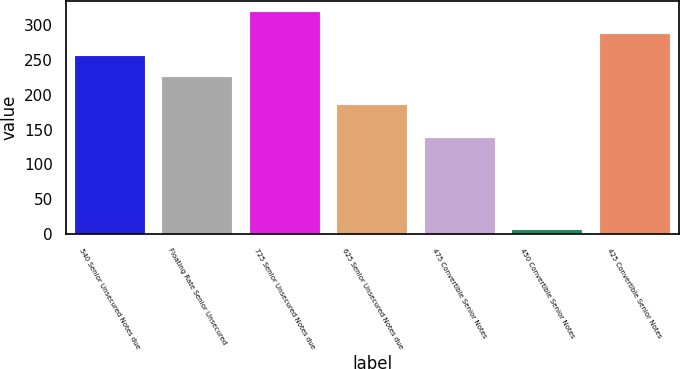Convert chart to OTSL. <chart><loc_0><loc_0><loc_500><loc_500><bar_chart><fcel>540 Senior Unsecured Notes due<fcel>Floating Rate Senior Unsecured<fcel>725 Senior Unsecured Notes due<fcel>625 Senior Unsecured Notes due<fcel>475 Convertible Senior Notes<fcel>450 Convertible Senior Notes<fcel>425 Convertible Senior Notes<nl><fcel>255.93<fcel>225<fcel>318.93<fcel>185.5<fcel>137.4<fcel>5.7<fcel>288<nl></chart> 